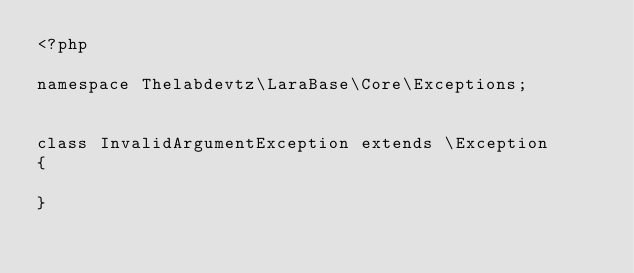Convert code to text. <code><loc_0><loc_0><loc_500><loc_500><_PHP_><?php

namespace Thelabdevtz\LaraBase\Core\Exceptions;


class InvalidArgumentException extends \Exception
{

}</code> 